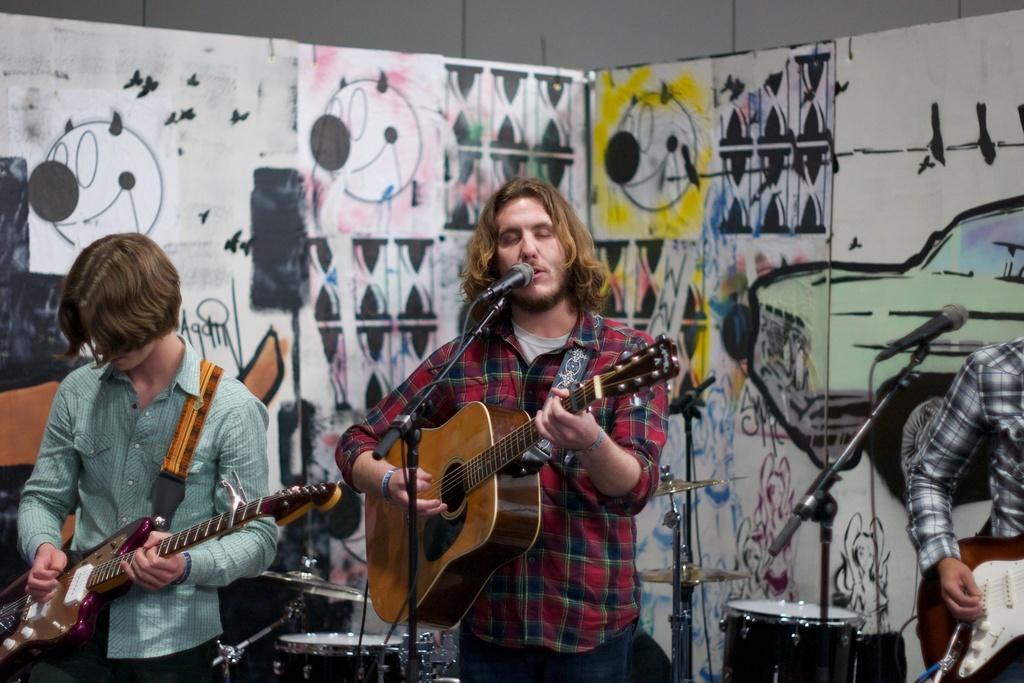How would you summarize this image in a sentence or two? There is a man standing and playing a guitar , another man standing and playing guitar , another person standing and playing guitar and at the background there is a microphone , mic stand , drums , cymbals and a paper drawings board. 